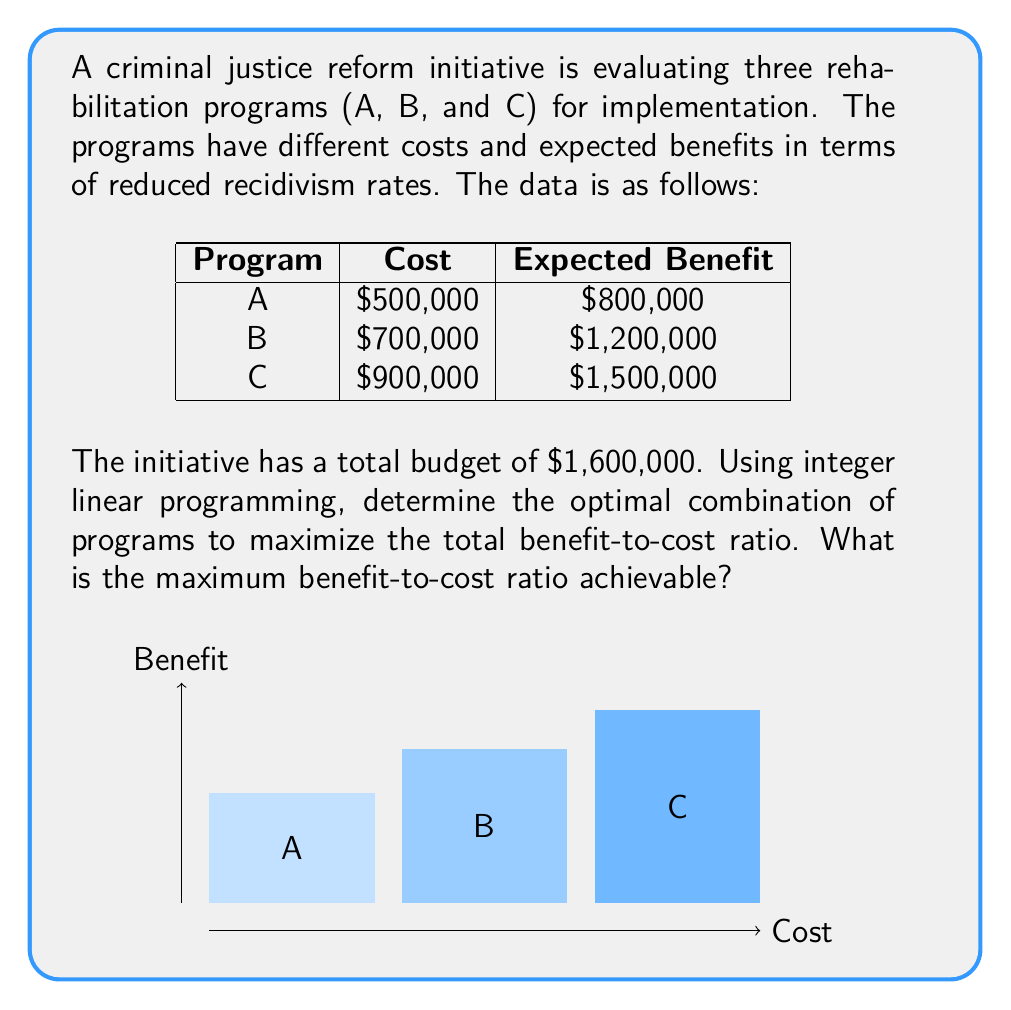Show me your answer to this math problem. Let's approach this step-by-step using integer linear programming:

1) Define variables:
   Let $x_A$, $x_B$, and $x_C$ be binary variables representing whether we choose program A, B, or C respectively.

2) Objective function:
   We want to maximize the benefit-to-cost ratio. This can be expressed as:
   
   $$\text{Maximize } \frac{800000x_A + 1200000x_B + 1500000x_C}{500000x_A + 700000x_B + 900000x_C}$$

3) Constraints:
   Budget constraint: $500000x_A + 700000x_B + 900000x_C \leq 1600000$
   Binary constraints: $x_A, x_B, x_C \in \{0,1\}$

4) This is a fractional programming problem, which can be solved by enumerating all possible combinations:

   - A only: $\frac{800000}{500000} = 1.6$
   - B only: $\frac{1200000}{700000} \approx 1.714$
   - C only: $\frac{1500000}{900000} \approx 1.667$
   - A and B: $\frac{2000000}{1200000} \approx 1.667$
   - A and C: Not feasible (over budget)
   - B and C: Not feasible (over budget)
   - A, B, and C: Not feasible (over budget)

5) The highest ratio is achieved by choosing only Program B.

6) Calculate the maximum benefit-to-cost ratio:
   $$\frac{1200000}{700000} = \frac{12}{7} \approx 1.714$$
Answer: $\frac{12}{7}$ or approximately 1.714 